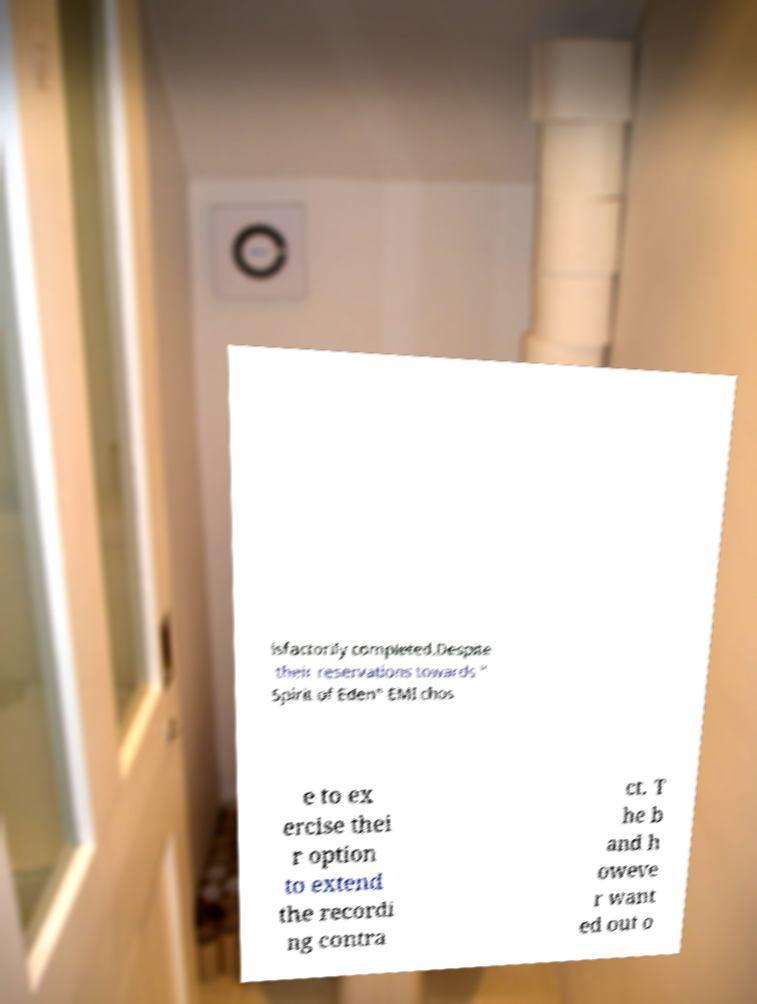Could you assist in decoding the text presented in this image and type it out clearly? isfactorily completed.Despite their reservations towards " Spirit of Eden" EMI chos e to ex ercise thei r option to extend the recordi ng contra ct. T he b and h oweve r want ed out o 